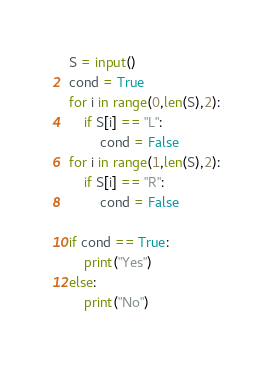Convert code to text. <code><loc_0><loc_0><loc_500><loc_500><_Python_>S = input()
cond = True
for i in range(0,len(S),2):
	if S[i] == "L":
		cond = False
for i in range(1,len(S),2):
	if S[i] == "R":
		cond = False

if cond == True:
	print("Yes")
else:
	print("No")</code> 